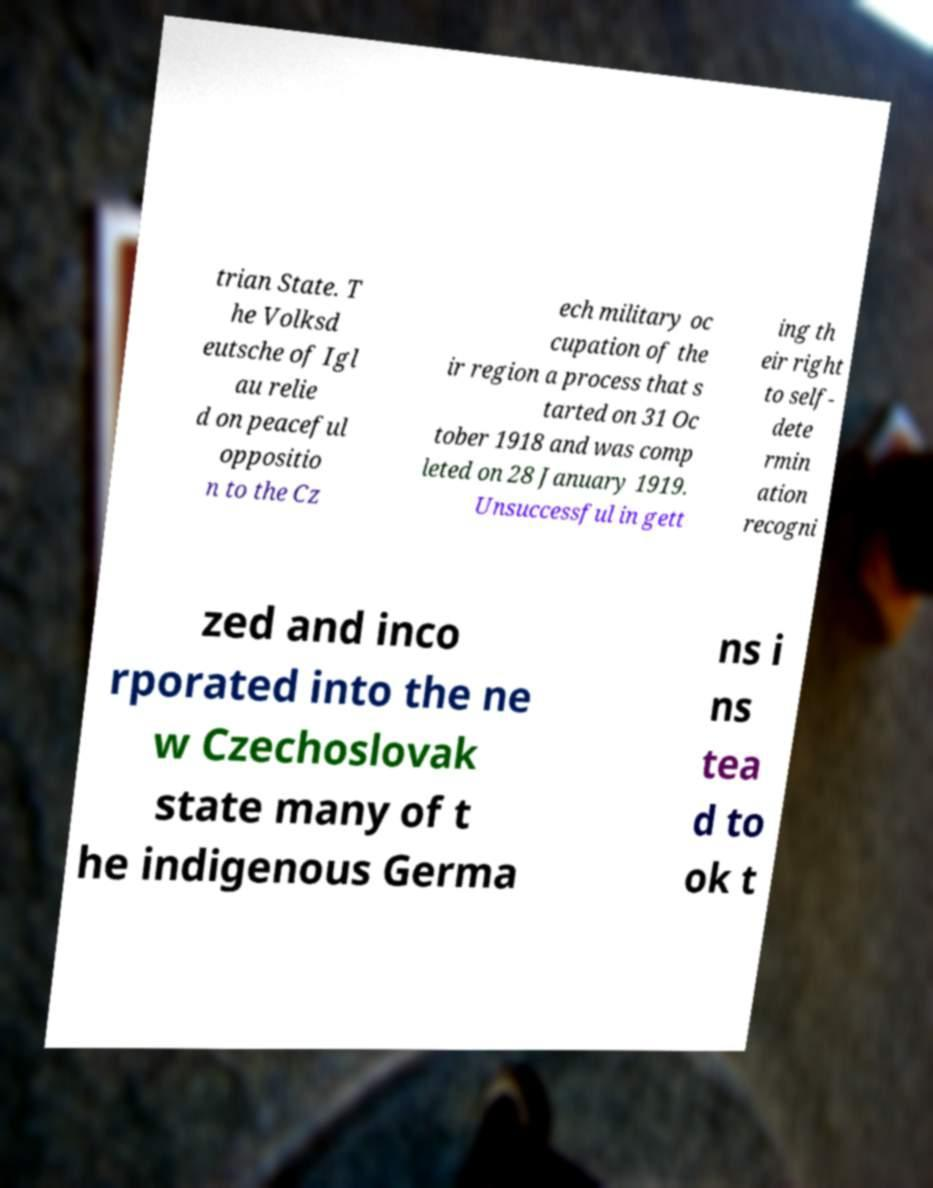I need the written content from this picture converted into text. Can you do that? trian State. T he Volksd eutsche of Igl au relie d on peaceful oppositio n to the Cz ech military oc cupation of the ir region a process that s tarted on 31 Oc tober 1918 and was comp leted on 28 January 1919. Unsuccessful in gett ing th eir right to self- dete rmin ation recogni zed and inco rporated into the ne w Czechoslovak state many of t he indigenous Germa ns i ns tea d to ok t 